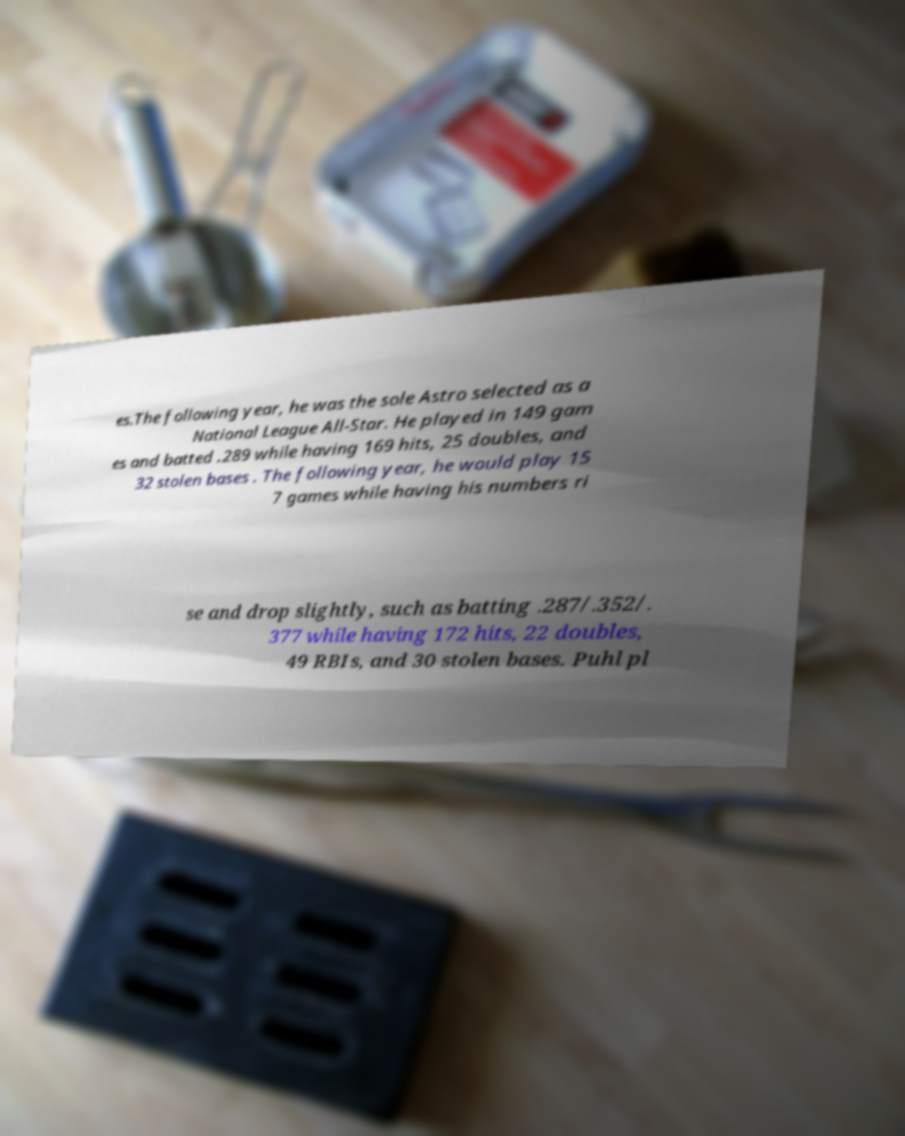Could you extract and type out the text from this image? es.The following year, he was the sole Astro selected as a National League All-Star. He played in 149 gam es and batted .289 while having 169 hits, 25 doubles, and 32 stolen bases . The following year, he would play 15 7 games while having his numbers ri se and drop slightly, such as batting .287/.352/. 377 while having 172 hits, 22 doubles, 49 RBIs, and 30 stolen bases. Puhl pl 